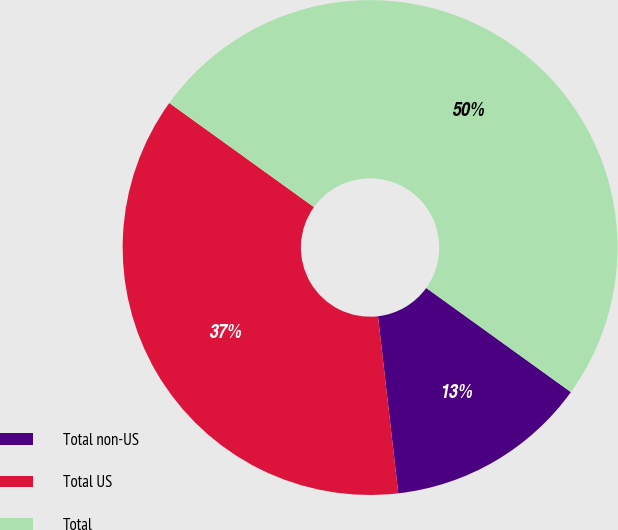Convert chart. <chart><loc_0><loc_0><loc_500><loc_500><pie_chart><fcel>Total non-US<fcel>Total US<fcel>Total<nl><fcel>13.25%<fcel>36.75%<fcel>50.0%<nl></chart> 